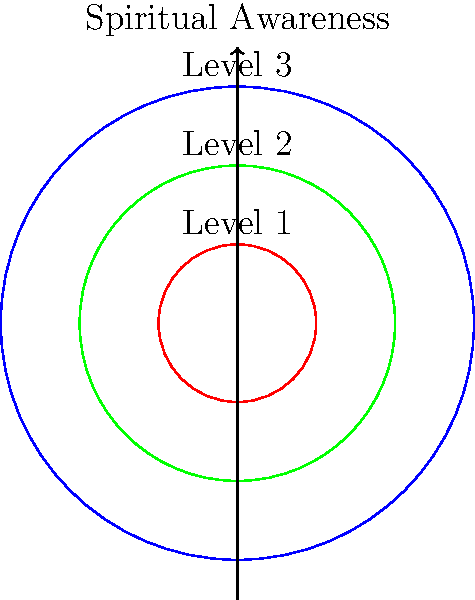Consider a space $X$ representing different levels of spiritual awareness during flight missions, modeled as three concentric circles. The innermost circle (Level 1) represents basic awareness, the middle circle (Level 2) represents intermediate awareness, and the outermost circle (Level 3) represents advanced awareness. Calculate the first homology group $H_1(X)$ of this space. To calculate the first homology group $H_1(X)$ of the space $X$, we'll follow these steps:

1) First, observe that the space $X$ is homotopy equivalent to three points, as each circle can be contracted to a point.

2) The 0-dimensional homology group $H_0(X)$ counts the number of connected components. Since all circles are connected, $H_0(X) \cong \mathbb{Z}$.

3) For the 1-dimensional homology group $H_1(X)$, we need to consider 1-cycles that are not boundaries of 2-chains. In this case, there are no non-trivial 1-cycles because:
   a) Any loop in a single circle can be contracted to a point.
   b) Any loop encompassing multiple circles can be deformed to a point by sliding it off the outermost circle.

4) Therefore, there are no non-trivial 1-cycles, and $H_1(X) \cong 0$ (the trivial group).

5) Higher homology groups ($H_n(X)$ for $n \geq 2$) are also trivial because the space is essentially 0-dimensional after contraction.

Thus, the first homology group $H_1(X)$ is the trivial group, often denoted as 0.
Answer: $H_1(X) \cong 0$ 